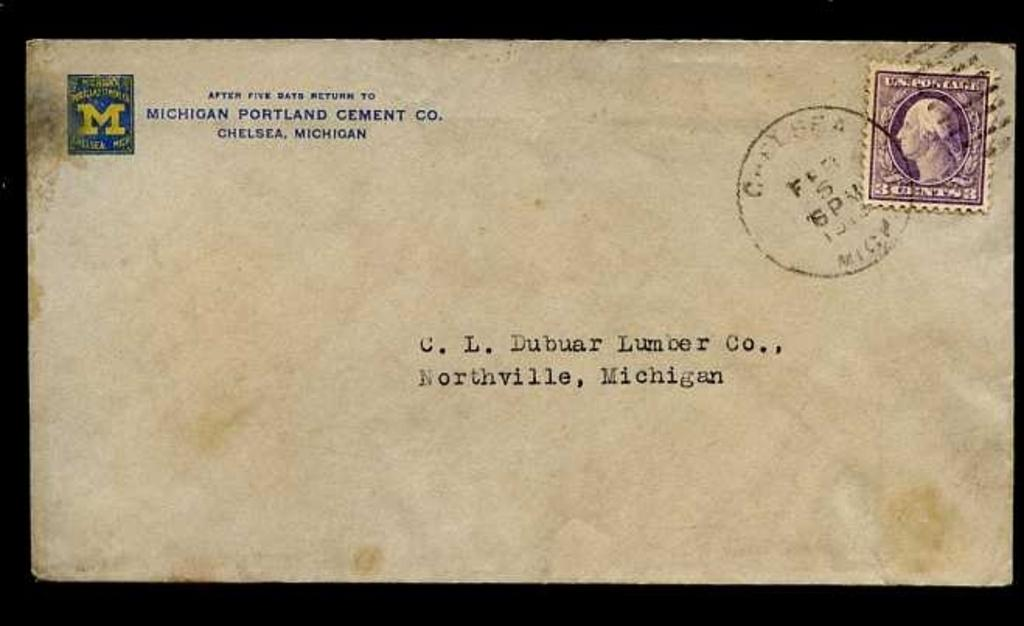<image>
Create a compact narrative representing the image presented. A letter is adressed to the C.L. Dubuar Lumber Company in Northville, Michigan. 